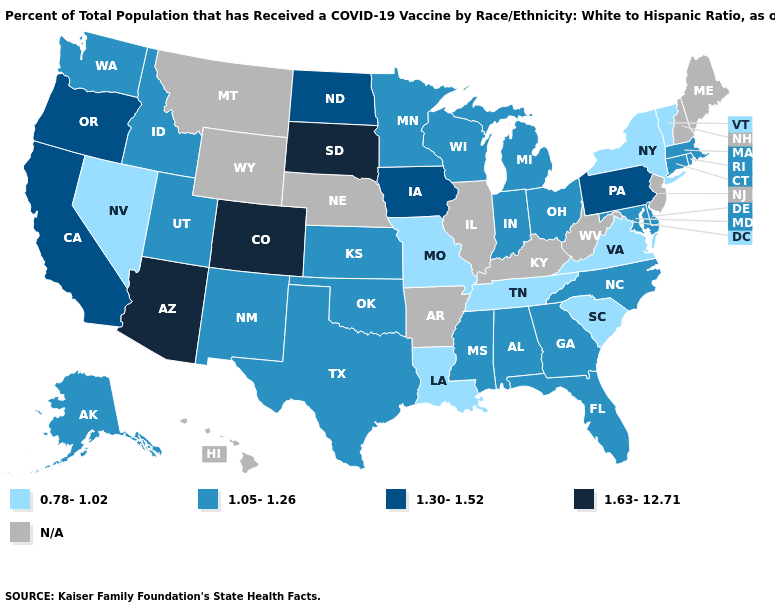What is the value of Alaska?
Give a very brief answer. 1.05-1.26. Which states have the highest value in the USA?
Give a very brief answer. Arizona, Colorado, South Dakota. Name the states that have a value in the range 0.78-1.02?
Be succinct. Louisiana, Missouri, Nevada, New York, South Carolina, Tennessee, Vermont, Virginia. What is the value of Alaska?
Concise answer only. 1.05-1.26. What is the value of Wyoming?
Keep it brief. N/A. Name the states that have a value in the range 0.78-1.02?
Quick response, please. Louisiana, Missouri, Nevada, New York, South Carolina, Tennessee, Vermont, Virginia. What is the value of Illinois?
Give a very brief answer. N/A. Name the states that have a value in the range N/A?
Be succinct. Arkansas, Hawaii, Illinois, Kentucky, Maine, Montana, Nebraska, New Hampshire, New Jersey, West Virginia, Wyoming. Name the states that have a value in the range 1.30-1.52?
Answer briefly. California, Iowa, North Dakota, Oregon, Pennsylvania. Does Arizona have the highest value in the USA?
Give a very brief answer. Yes. What is the value of Maine?
Quick response, please. N/A. Which states have the lowest value in the MidWest?
Write a very short answer. Missouri. What is the lowest value in the USA?
Short answer required. 0.78-1.02. 